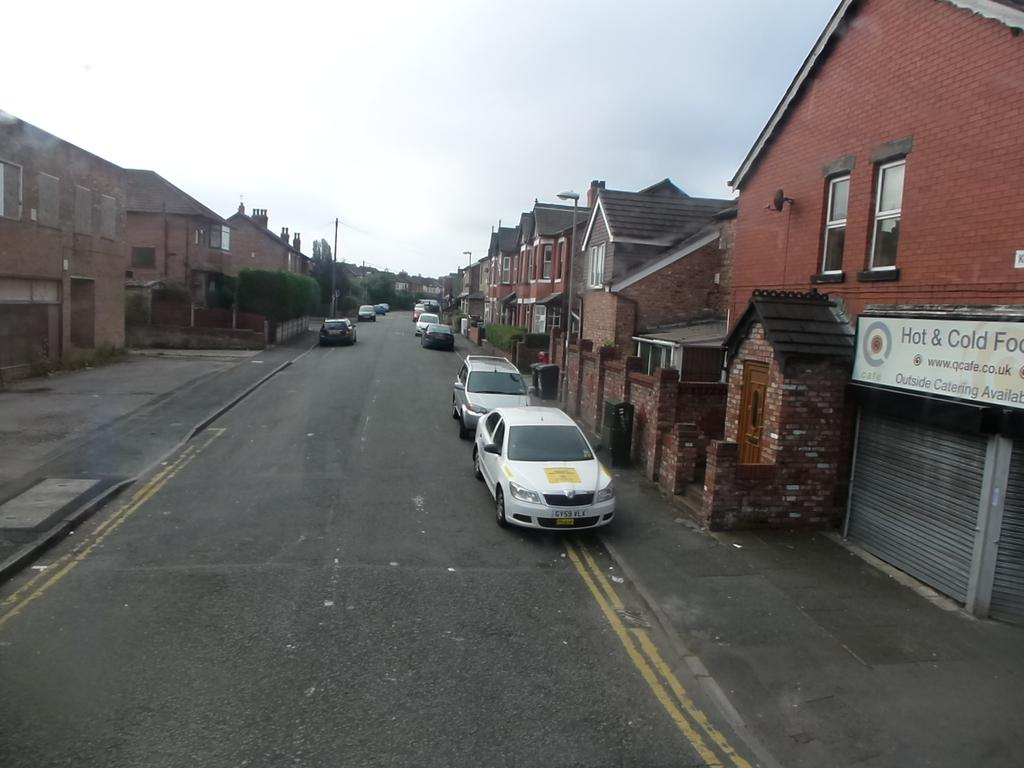What can be seen on the road in the image? There are vehicles on the road in the image. What else is visible in the image besides the vehicles? There are buildings and street lights visible in the image. What might be used for displaying information or advertisements in the image? There is a board with writing in the image. What is visible in the background of the image? The sky is visible in the background of the image. How many oranges are on the board in the image? There are no oranges present on the board or anywhere else in the image. 